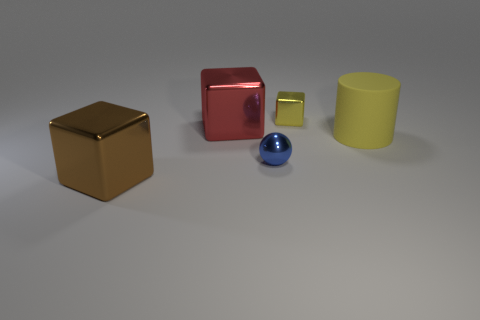Is there anything else that has the same material as the large yellow cylinder?
Offer a very short reply. No. There is a metal block in front of the yellow cylinder; what size is it?
Provide a succinct answer. Large. What size is the blue sphere that is the same material as the large brown cube?
Your response must be concise. Small. How many big cylinders are the same color as the small shiny block?
Your answer should be compact. 1. Are there any blue metallic things?
Provide a succinct answer. Yes. Is the shape of the yellow shiny thing the same as the big shiny thing behind the blue shiny thing?
Offer a very short reply. Yes. The cylinder to the right of the large thing behind the yellow thing in front of the yellow metallic object is what color?
Provide a succinct answer. Yellow. Are there any big yellow matte objects to the right of the tiny blue shiny object?
Ensure brevity in your answer.  Yes. The cube that is the same color as the cylinder is what size?
Your response must be concise. Small. Is there a large yellow thing made of the same material as the small yellow cube?
Give a very brief answer. No. 